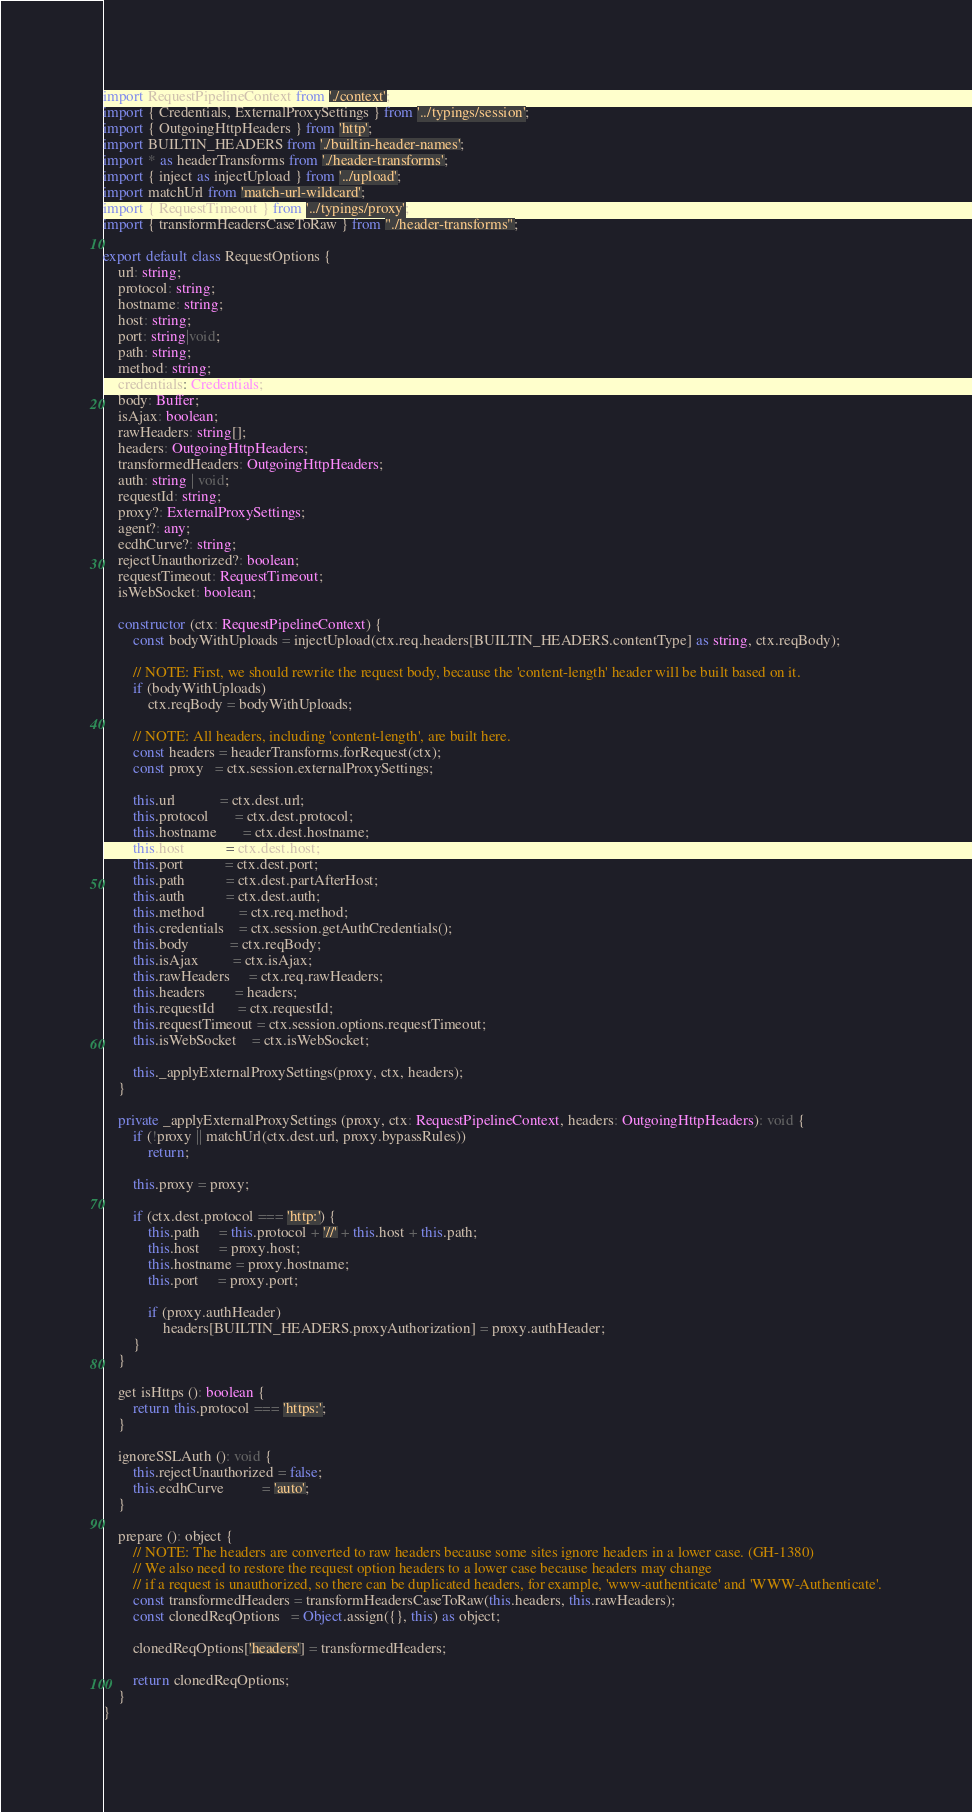Convert code to text. <code><loc_0><loc_0><loc_500><loc_500><_TypeScript_>import RequestPipelineContext from './context';
import { Credentials, ExternalProxySettings } from '../typings/session';
import { OutgoingHttpHeaders } from 'http';
import BUILTIN_HEADERS from './builtin-header-names';
import * as headerTransforms from './header-transforms';
import { inject as injectUpload } from '../upload';
import matchUrl from 'match-url-wildcard';
import { RequestTimeout } from '../typings/proxy';
import { transformHeadersCaseToRaw } from "./header-transforms";

export default class RequestOptions {
    url: string;
    protocol: string;
    hostname: string;
    host: string;
    port: string|void;
    path: string;
    method: string;
    credentials: Credentials;
    body: Buffer;
    isAjax: boolean;
    rawHeaders: string[];
    headers: OutgoingHttpHeaders;
    transformedHeaders: OutgoingHttpHeaders;
    auth: string | void;
    requestId: string;
    proxy?: ExternalProxySettings;
    agent?: any;
    ecdhCurve?: string;
    rejectUnauthorized?: boolean;
    requestTimeout: RequestTimeout;
    isWebSocket: boolean;

    constructor (ctx: RequestPipelineContext) {
        const bodyWithUploads = injectUpload(ctx.req.headers[BUILTIN_HEADERS.contentType] as string, ctx.reqBody);

        // NOTE: First, we should rewrite the request body, because the 'content-length' header will be built based on it.
        if (bodyWithUploads)
            ctx.reqBody = bodyWithUploads;

        // NOTE: All headers, including 'content-length', are built here.
        const headers = headerTransforms.forRequest(ctx);
        const proxy   = ctx.session.externalProxySettings;

        this.url            = ctx.dest.url;
        this.protocol       = ctx.dest.protocol;
        this.hostname       = ctx.dest.hostname;
        this.host           = ctx.dest.host;
        this.port           = ctx.dest.port;
        this.path           = ctx.dest.partAfterHost;
        this.auth           = ctx.dest.auth;
        this.method         = ctx.req.method;
        this.credentials    = ctx.session.getAuthCredentials();
        this.body           = ctx.reqBody;
        this.isAjax         = ctx.isAjax;
        this.rawHeaders     = ctx.req.rawHeaders;
        this.headers        = headers;
        this.requestId      = ctx.requestId;
        this.requestTimeout = ctx.session.options.requestTimeout;
        this.isWebSocket    = ctx.isWebSocket;

        this._applyExternalProxySettings(proxy, ctx, headers);
    }

    private _applyExternalProxySettings (proxy, ctx: RequestPipelineContext, headers: OutgoingHttpHeaders): void {
        if (!proxy || matchUrl(ctx.dest.url, proxy.bypassRules))
            return;

        this.proxy = proxy;

        if (ctx.dest.protocol === 'http:') {
            this.path     = this.protocol + '//' + this.host + this.path;
            this.host     = proxy.host;
            this.hostname = proxy.hostname;
            this.port     = proxy.port;

            if (proxy.authHeader)
                headers[BUILTIN_HEADERS.proxyAuthorization] = proxy.authHeader;
        }
    }

    get isHttps (): boolean {
        return this.protocol === 'https:';
    }

    ignoreSSLAuth (): void {
        this.rejectUnauthorized = false;
        this.ecdhCurve          = 'auto';
    }

    prepare (): object {
        // NOTE: The headers are converted to raw headers because some sites ignore headers in a lower case. (GH-1380)
        // We also need to restore the request option headers to a lower case because headers may change
        // if a request is unauthorized, so there can be duplicated headers, for example, 'www-authenticate' and 'WWW-Authenticate'.
        const transformedHeaders = transformHeadersCaseToRaw(this.headers, this.rawHeaders);
        const clonedReqOptions   = Object.assign({}, this) as object;

        clonedReqOptions['headers'] = transformedHeaders;

        return clonedReqOptions;
    }
}
</code> 